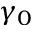<formula> <loc_0><loc_0><loc_500><loc_500>\gamma _ { 0 }</formula> 